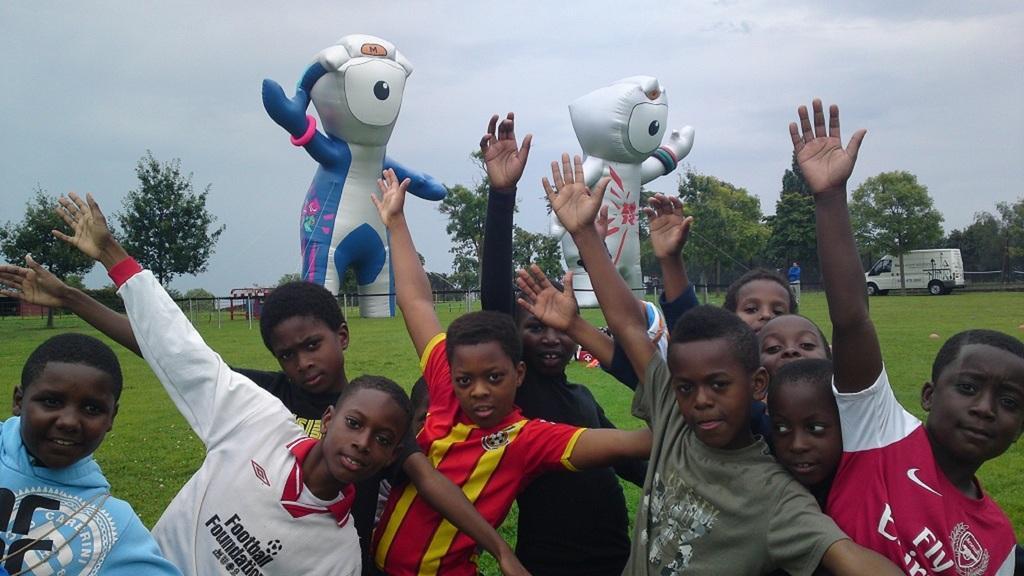Describe this image in one or two sentences. In the center of the image we can see a few kids are standing and they are in different costumes. In the background, we can see the sky, clouds, trees, grass, toys, one vehicle, one person is standing and a few other objects. 